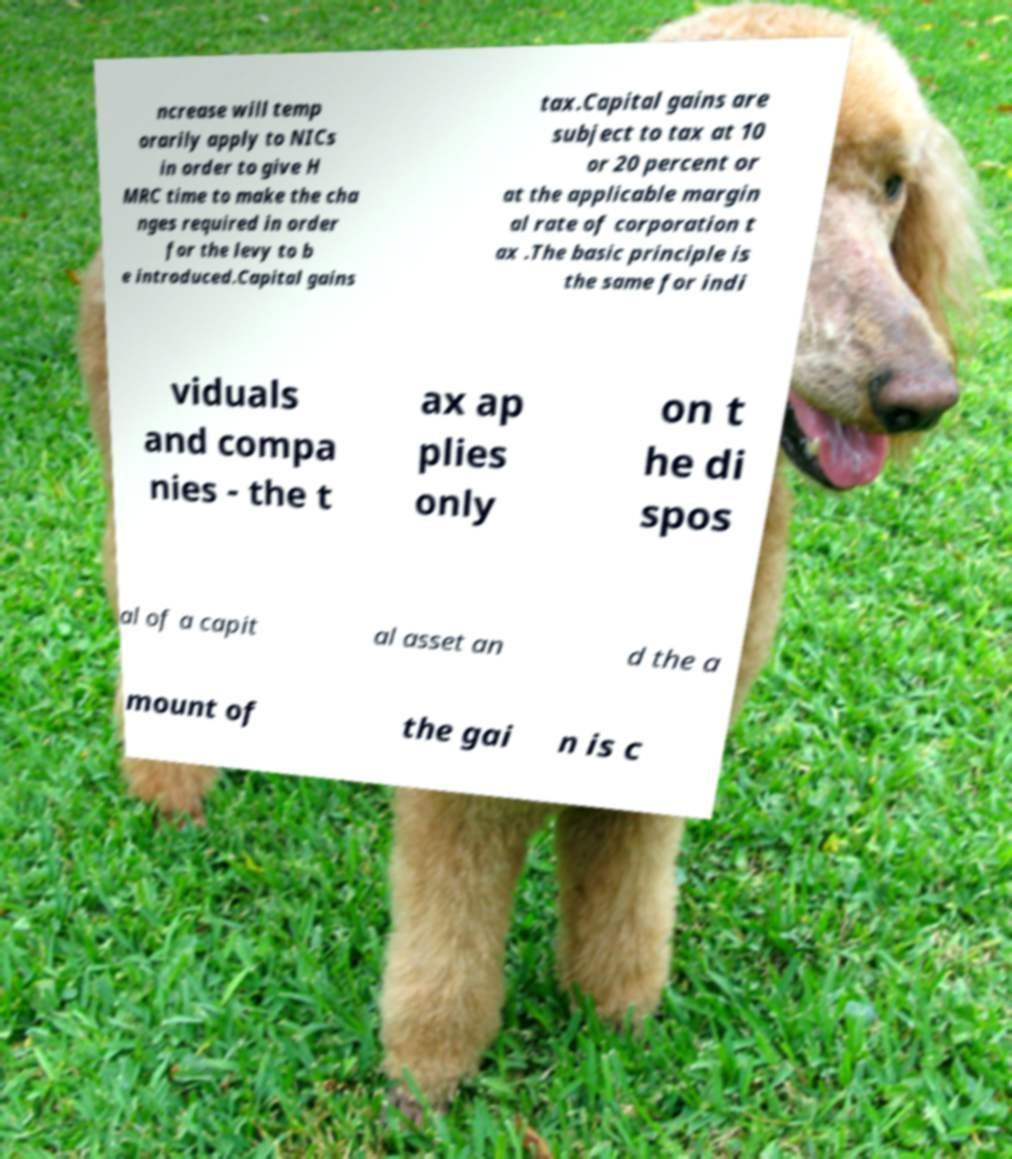Please read and relay the text visible in this image. What does it say? ncrease will temp orarily apply to NICs in order to give H MRC time to make the cha nges required in order for the levy to b e introduced.Capital gains tax.Capital gains are subject to tax at 10 or 20 percent or at the applicable margin al rate of corporation t ax .The basic principle is the same for indi viduals and compa nies - the t ax ap plies only on t he di spos al of a capit al asset an d the a mount of the gai n is c 